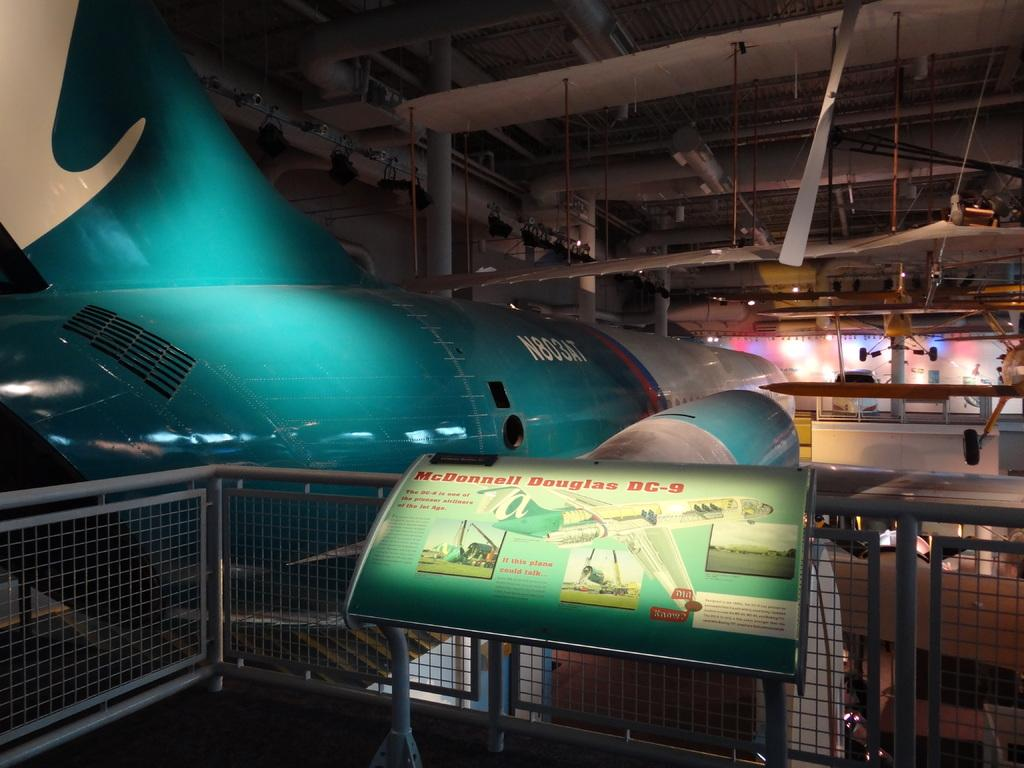<image>
Write a terse but informative summary of the picture. a plane that has a sign in front of it that says 'mcdonnell douglas bc-9' 